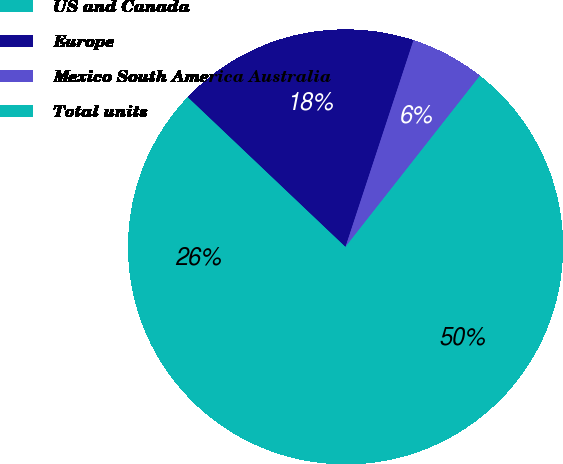<chart> <loc_0><loc_0><loc_500><loc_500><pie_chart><fcel>US and Canada<fcel>Europe<fcel>Mexico South America Australia<fcel>Total units<nl><fcel>26.49%<fcel>17.97%<fcel>5.54%<fcel>50.0%<nl></chart> 